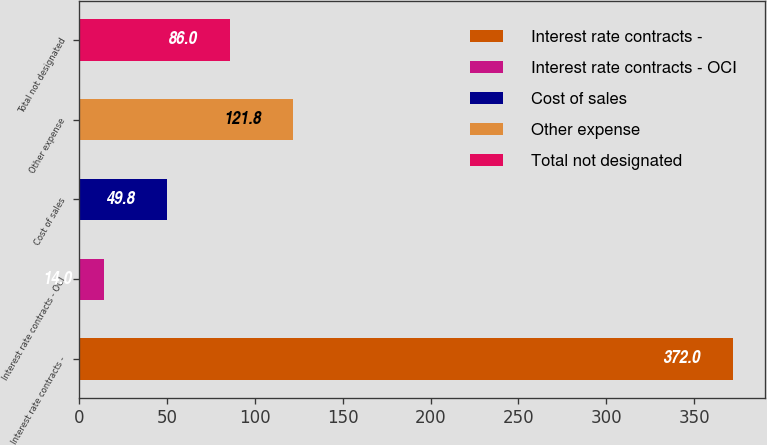Convert chart. <chart><loc_0><loc_0><loc_500><loc_500><bar_chart><fcel>Interest rate contracts -<fcel>Interest rate contracts - OCI<fcel>Cost of sales<fcel>Other expense<fcel>Total not designated<nl><fcel>372<fcel>14<fcel>49.8<fcel>121.8<fcel>86<nl></chart> 